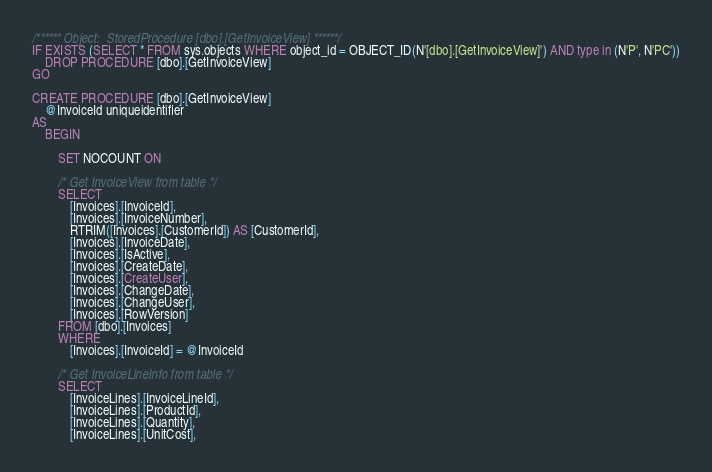Convert code to text. <code><loc_0><loc_0><loc_500><loc_500><_SQL_>/****** Object:  StoredProcedure [dbo].[GetInvoiceView] ******/
IF EXISTS (SELECT * FROM sys.objects WHERE object_id = OBJECT_ID(N'[dbo].[GetInvoiceView]') AND type in (N'P', N'PC'))
    DROP PROCEDURE [dbo].[GetInvoiceView]
GO

CREATE PROCEDURE [dbo].[GetInvoiceView]
    @InvoiceId uniqueidentifier
AS
    BEGIN

        SET NOCOUNT ON

        /* Get InvoiceView from table */
        SELECT
            [Invoices].[InvoiceId],
            [Invoices].[InvoiceNumber],
            RTRIM([Invoices].[CustomerId]) AS [CustomerId],
            [Invoices].[InvoiceDate],
            [Invoices].[IsActive],
            [Invoices].[CreateDate],
            [Invoices].[CreateUser],
            [Invoices].[ChangeDate],
            [Invoices].[ChangeUser],
            [Invoices].[RowVersion]
        FROM [dbo].[Invoices]
        WHERE
            [Invoices].[InvoiceId] = @InvoiceId

        /* Get InvoiceLineInfo from table */
        SELECT
            [InvoiceLines].[InvoiceLineId],
            [InvoiceLines].[ProductId],
            [InvoiceLines].[Quantity],
            [InvoiceLines].[UnitCost],</code> 